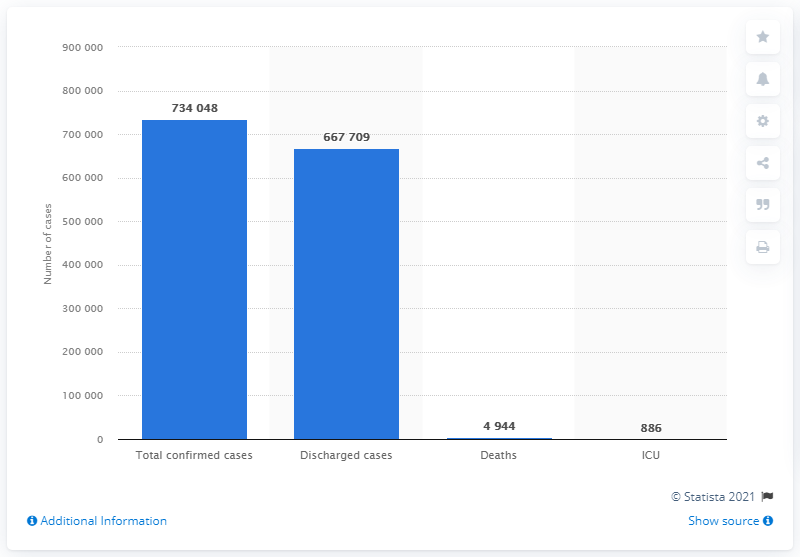Indicate a few pertinent items in this graphic. There are two tiny bars present in this chart. In Malaysia, the percentage of discharged cases among the total confirmed cases is 90.9%. 